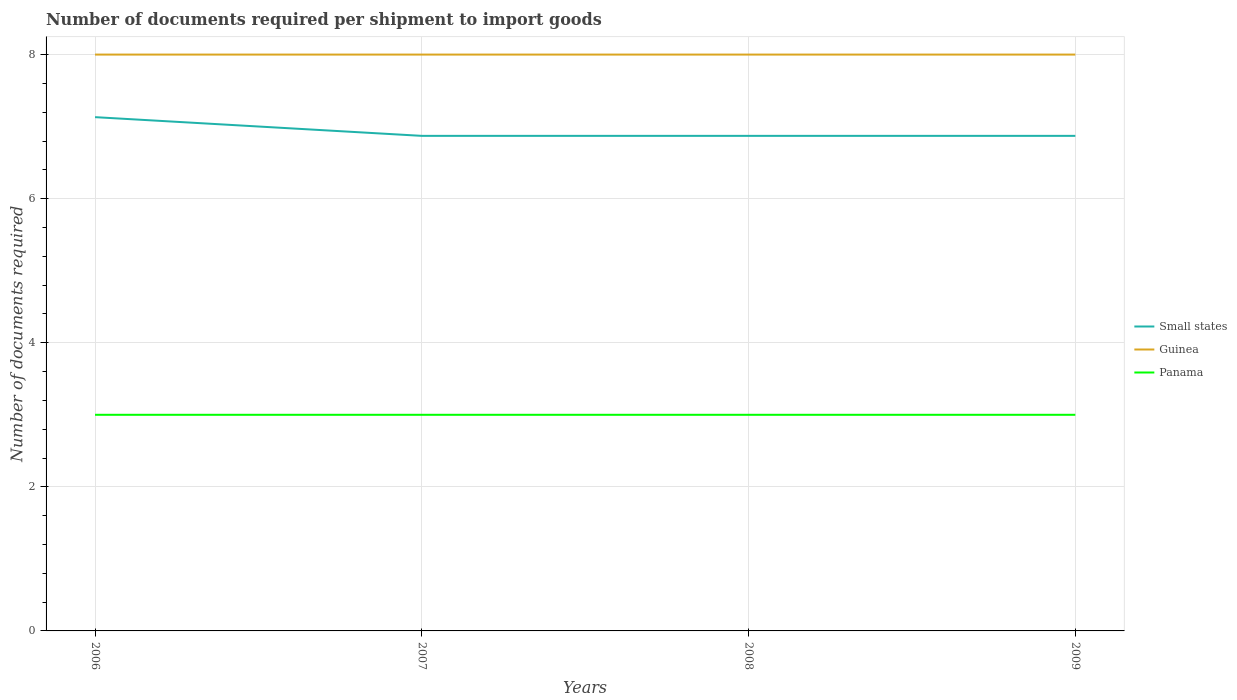How many different coloured lines are there?
Provide a succinct answer. 3. Is the number of lines equal to the number of legend labels?
Provide a short and direct response. Yes. Across all years, what is the maximum number of documents required per shipment to import goods in Small states?
Your answer should be compact. 6.87. In which year was the number of documents required per shipment to import goods in Panama maximum?
Ensure brevity in your answer.  2006. What is the total number of documents required per shipment to import goods in Small states in the graph?
Ensure brevity in your answer.  0.26. What is the difference between the highest and the second highest number of documents required per shipment to import goods in Small states?
Your response must be concise. 0.26. What is the difference between the highest and the lowest number of documents required per shipment to import goods in Guinea?
Provide a short and direct response. 0. Is the number of documents required per shipment to import goods in Small states strictly greater than the number of documents required per shipment to import goods in Guinea over the years?
Provide a succinct answer. Yes. How many lines are there?
Provide a succinct answer. 3. How many years are there in the graph?
Give a very brief answer. 4. Does the graph contain grids?
Ensure brevity in your answer.  Yes. How many legend labels are there?
Offer a terse response. 3. How are the legend labels stacked?
Your answer should be compact. Vertical. What is the title of the graph?
Offer a very short reply. Number of documents required per shipment to import goods. Does "Australia" appear as one of the legend labels in the graph?
Offer a terse response. No. What is the label or title of the Y-axis?
Your response must be concise. Number of documents required. What is the Number of documents required of Small states in 2006?
Your response must be concise. 7.13. What is the Number of documents required of Guinea in 2006?
Your response must be concise. 8. What is the Number of documents required in Small states in 2007?
Keep it short and to the point. 6.87. What is the Number of documents required of Panama in 2007?
Keep it short and to the point. 3. What is the Number of documents required of Small states in 2008?
Give a very brief answer. 6.87. What is the Number of documents required of Panama in 2008?
Offer a very short reply. 3. What is the Number of documents required of Small states in 2009?
Provide a succinct answer. 6.87. What is the Number of documents required in Guinea in 2009?
Make the answer very short. 8. Across all years, what is the maximum Number of documents required in Small states?
Your answer should be compact. 7.13. Across all years, what is the maximum Number of documents required of Guinea?
Keep it short and to the point. 8. Across all years, what is the maximum Number of documents required in Panama?
Keep it short and to the point. 3. Across all years, what is the minimum Number of documents required of Small states?
Your answer should be compact. 6.87. Across all years, what is the minimum Number of documents required in Guinea?
Provide a short and direct response. 8. What is the total Number of documents required of Small states in the graph?
Provide a succinct answer. 27.75. What is the total Number of documents required of Panama in the graph?
Keep it short and to the point. 12. What is the difference between the Number of documents required of Small states in 2006 and that in 2007?
Your answer should be compact. 0.26. What is the difference between the Number of documents required of Small states in 2006 and that in 2008?
Ensure brevity in your answer.  0.26. What is the difference between the Number of documents required of Small states in 2006 and that in 2009?
Ensure brevity in your answer.  0.26. What is the difference between the Number of documents required of Panama in 2007 and that in 2008?
Make the answer very short. 0. What is the difference between the Number of documents required in Small states in 2007 and that in 2009?
Make the answer very short. 0. What is the difference between the Number of documents required in Guinea in 2007 and that in 2009?
Provide a short and direct response. 0. What is the difference between the Number of documents required of Panama in 2008 and that in 2009?
Provide a short and direct response. 0. What is the difference between the Number of documents required in Small states in 2006 and the Number of documents required in Guinea in 2007?
Give a very brief answer. -0.87. What is the difference between the Number of documents required in Small states in 2006 and the Number of documents required in Panama in 2007?
Provide a short and direct response. 4.13. What is the difference between the Number of documents required in Small states in 2006 and the Number of documents required in Guinea in 2008?
Offer a terse response. -0.87. What is the difference between the Number of documents required of Small states in 2006 and the Number of documents required of Panama in 2008?
Your answer should be compact. 4.13. What is the difference between the Number of documents required of Small states in 2006 and the Number of documents required of Guinea in 2009?
Your answer should be compact. -0.87. What is the difference between the Number of documents required of Small states in 2006 and the Number of documents required of Panama in 2009?
Make the answer very short. 4.13. What is the difference between the Number of documents required of Small states in 2007 and the Number of documents required of Guinea in 2008?
Ensure brevity in your answer.  -1.13. What is the difference between the Number of documents required of Small states in 2007 and the Number of documents required of Panama in 2008?
Ensure brevity in your answer.  3.87. What is the difference between the Number of documents required in Guinea in 2007 and the Number of documents required in Panama in 2008?
Provide a short and direct response. 5. What is the difference between the Number of documents required of Small states in 2007 and the Number of documents required of Guinea in 2009?
Ensure brevity in your answer.  -1.13. What is the difference between the Number of documents required in Small states in 2007 and the Number of documents required in Panama in 2009?
Keep it short and to the point. 3.87. What is the difference between the Number of documents required of Small states in 2008 and the Number of documents required of Guinea in 2009?
Provide a short and direct response. -1.13. What is the difference between the Number of documents required of Small states in 2008 and the Number of documents required of Panama in 2009?
Your answer should be very brief. 3.87. What is the difference between the Number of documents required in Guinea in 2008 and the Number of documents required in Panama in 2009?
Your response must be concise. 5. What is the average Number of documents required of Small states per year?
Your response must be concise. 6.94. In the year 2006, what is the difference between the Number of documents required of Small states and Number of documents required of Guinea?
Offer a terse response. -0.87. In the year 2006, what is the difference between the Number of documents required in Small states and Number of documents required in Panama?
Your answer should be compact. 4.13. In the year 2007, what is the difference between the Number of documents required of Small states and Number of documents required of Guinea?
Provide a short and direct response. -1.13. In the year 2007, what is the difference between the Number of documents required in Small states and Number of documents required in Panama?
Give a very brief answer. 3.87. In the year 2007, what is the difference between the Number of documents required in Guinea and Number of documents required in Panama?
Ensure brevity in your answer.  5. In the year 2008, what is the difference between the Number of documents required of Small states and Number of documents required of Guinea?
Your answer should be very brief. -1.13. In the year 2008, what is the difference between the Number of documents required in Small states and Number of documents required in Panama?
Your answer should be very brief. 3.87. In the year 2008, what is the difference between the Number of documents required of Guinea and Number of documents required of Panama?
Your answer should be very brief. 5. In the year 2009, what is the difference between the Number of documents required in Small states and Number of documents required in Guinea?
Offer a terse response. -1.13. In the year 2009, what is the difference between the Number of documents required in Small states and Number of documents required in Panama?
Keep it short and to the point. 3.87. In the year 2009, what is the difference between the Number of documents required in Guinea and Number of documents required in Panama?
Give a very brief answer. 5. What is the ratio of the Number of documents required in Small states in 2006 to that in 2007?
Offer a terse response. 1.04. What is the ratio of the Number of documents required of Guinea in 2006 to that in 2007?
Your response must be concise. 1. What is the ratio of the Number of documents required in Panama in 2006 to that in 2007?
Your answer should be compact. 1. What is the ratio of the Number of documents required of Small states in 2006 to that in 2008?
Provide a short and direct response. 1.04. What is the ratio of the Number of documents required of Panama in 2006 to that in 2008?
Give a very brief answer. 1. What is the ratio of the Number of documents required of Small states in 2006 to that in 2009?
Offer a terse response. 1.04. What is the ratio of the Number of documents required in Guinea in 2007 to that in 2008?
Give a very brief answer. 1. What is the ratio of the Number of documents required of Panama in 2007 to that in 2008?
Provide a short and direct response. 1. What is the ratio of the Number of documents required of Small states in 2007 to that in 2009?
Your answer should be very brief. 1. What is the ratio of the Number of documents required in Small states in 2008 to that in 2009?
Your answer should be very brief. 1. What is the difference between the highest and the second highest Number of documents required of Small states?
Make the answer very short. 0.26. What is the difference between the highest and the lowest Number of documents required in Small states?
Your response must be concise. 0.26. What is the difference between the highest and the lowest Number of documents required of Guinea?
Your answer should be compact. 0. What is the difference between the highest and the lowest Number of documents required in Panama?
Keep it short and to the point. 0. 